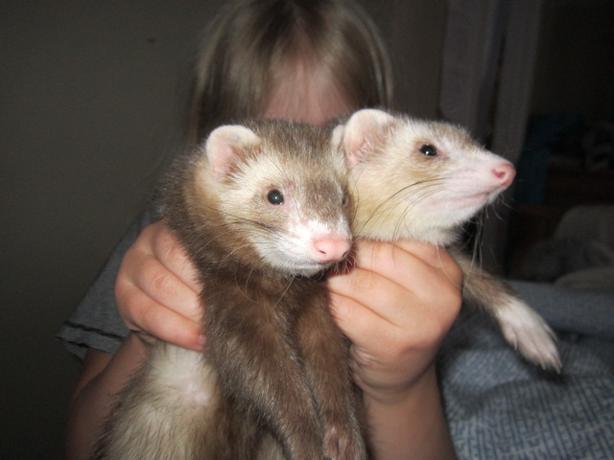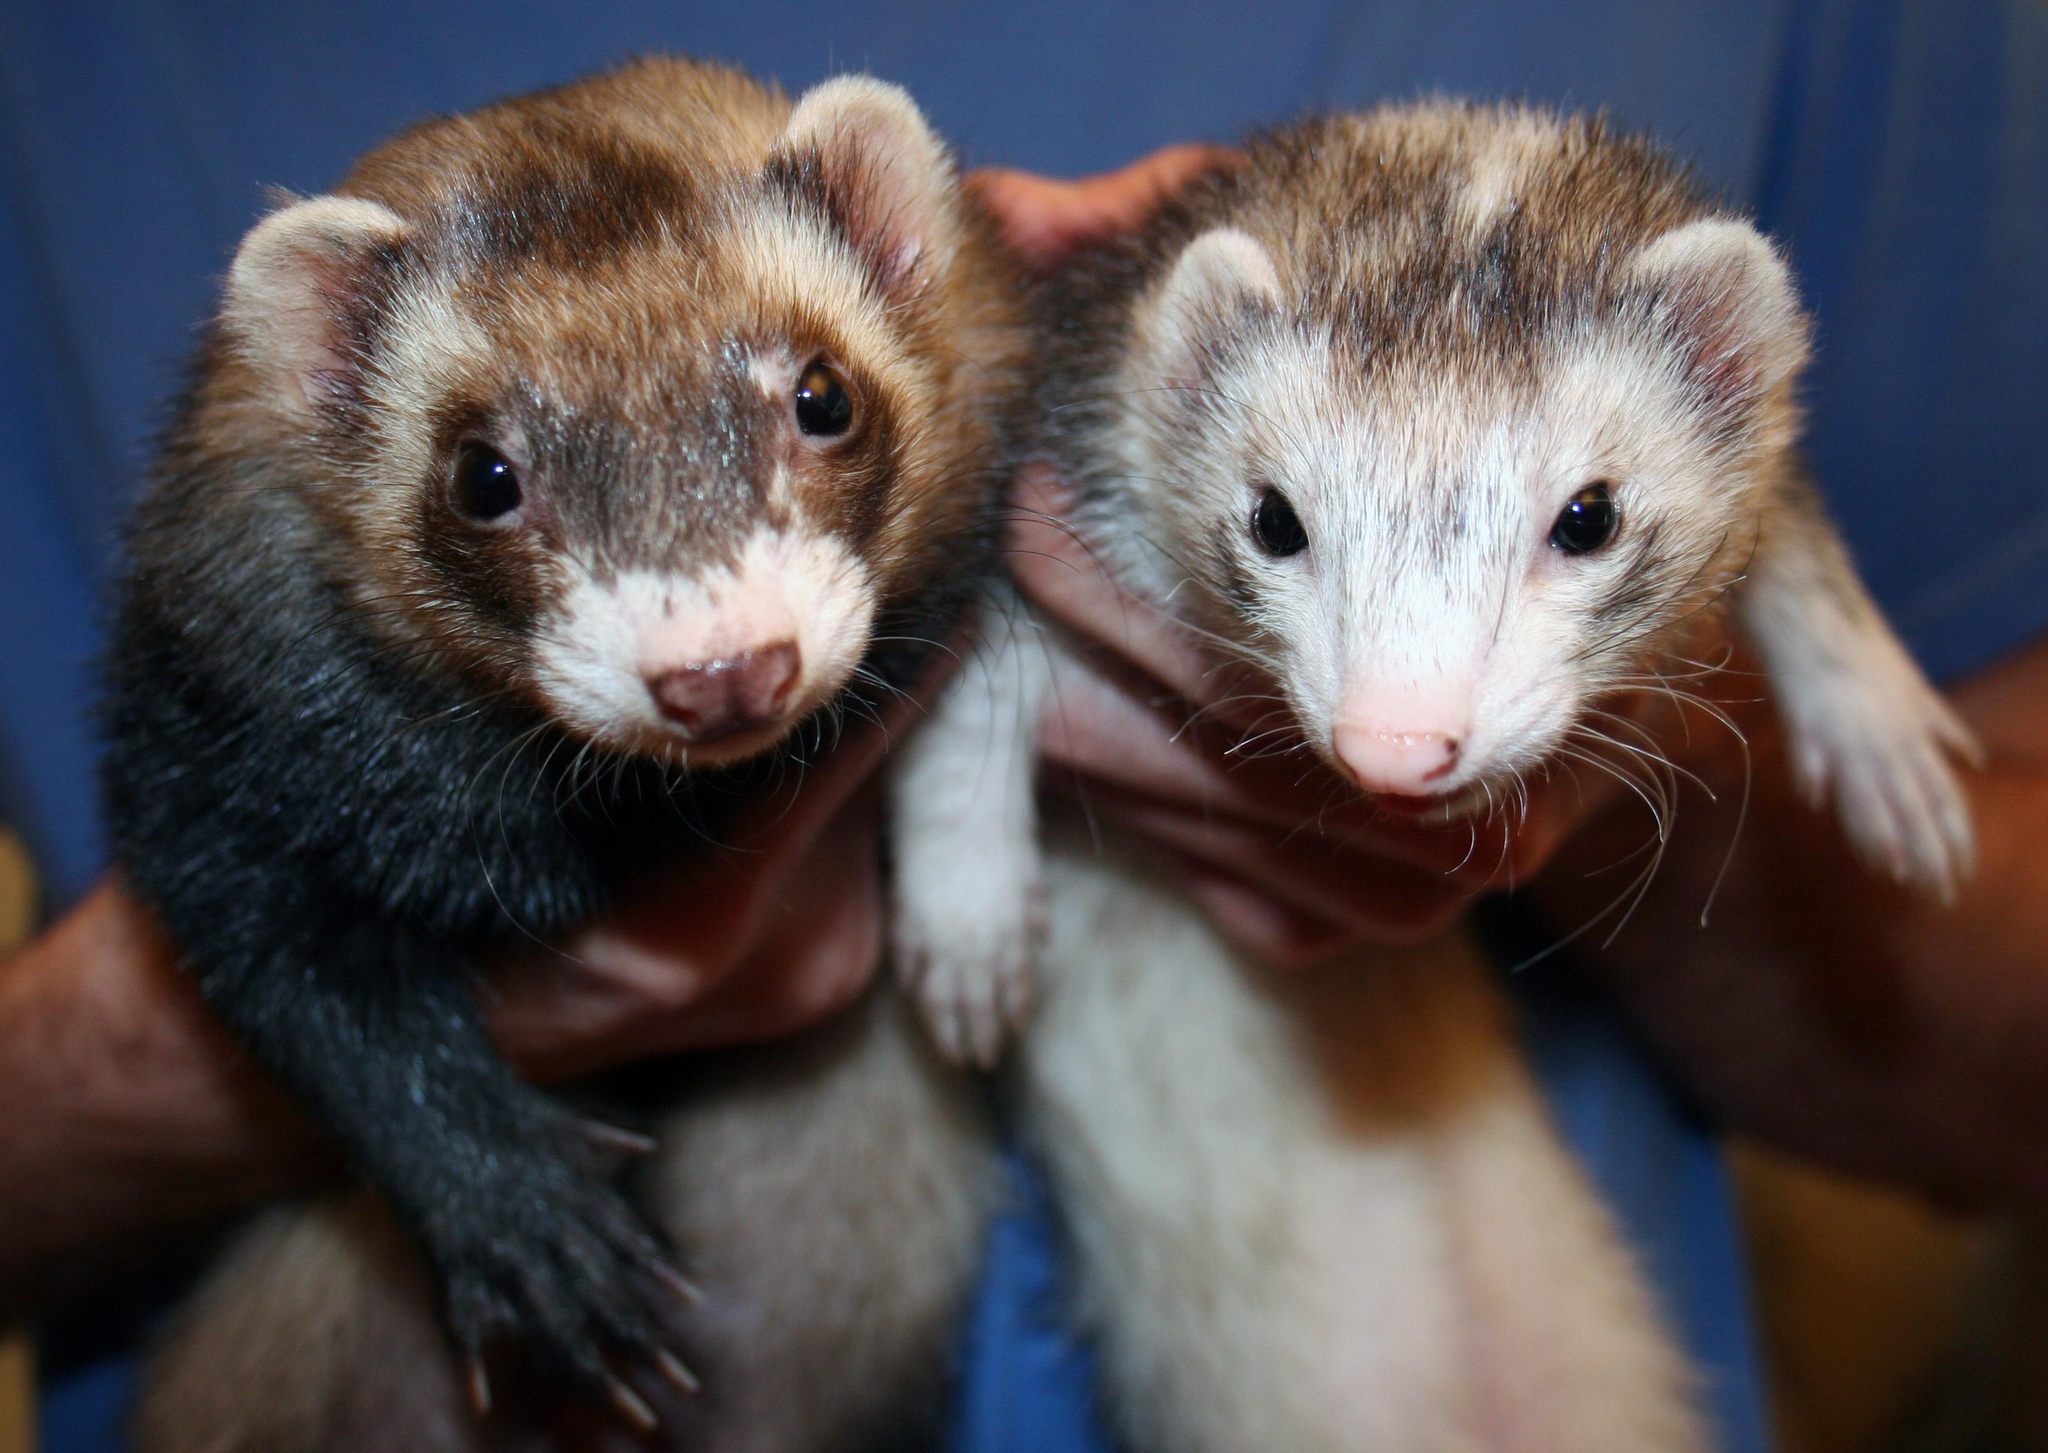The first image is the image on the left, the second image is the image on the right. For the images shown, is this caption "Someone is holding at least one of the animals." true? Answer yes or no. Yes. 